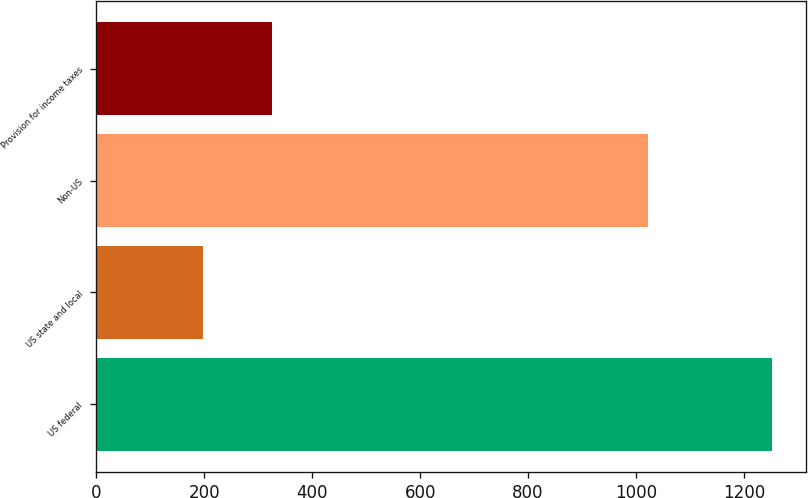<chart> <loc_0><loc_0><loc_500><loc_500><bar_chart><fcel>US federal<fcel>US state and local<fcel>Non-US<fcel>Provision for income taxes<nl><fcel>1252<fcel>198<fcel>1022<fcel>325.5<nl></chart> 